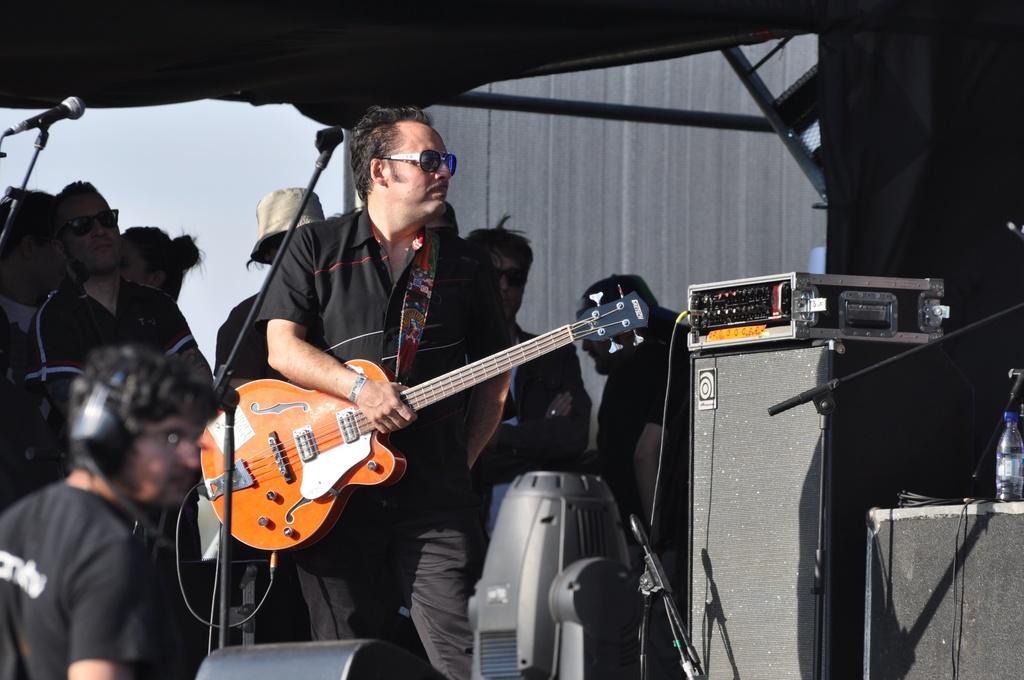How would you summarize this image in a sentence or two? A person wearing the goggles holding guitar and standing. There is a mic stand in front of him. In the background there is a wall, many people are standing. Also in the front there is a speaker, table and some other instruments are kept. Also in the right corner a bottle is on the speaker. 